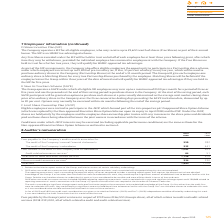According to Intu Properties's financial document, What were the fees payable by the Group's joint ventures in 2019? According to the financial document, £156,000. The relevant text states: "the Group’s joint ventures in respect of 2019 were £156,000 (Group’s share), all of which relates to audit and audit-related services (2018: £121,000, all of wh..." Also, What were the fees payable related to audit and audit-related services in 2018? According to the financial document, £121,000. The relevant text states: "relates to audit and audit-related services (2018: £121,000, all of which related to audit and audit-related services)...." Also, What is the total fees in 2019? According to the financial document, 1,690 (in thousands). The relevant text states: "Total fees 1,690 1,104..." Also, can you calculate: What is the percentage change in the total fees from 2018 to 2019? To answer this question, I need to perform calculations using the financial data. The calculation is: (1,690-1,104)/1,104, which equals 53.08 (percentage). This is based on the information: "Total fees 1,690 1,104 Total fees 1,690 1,104..." The key data points involved are: 1,104, 1,690. Also, can you calculate: What is the percentage change in the audit-related assurance services from 2018 to 2019? To answer this question, I need to perform calculations using the financial data. The calculation is: (64-51)/51, which equals 25.49 (percentage). This is based on the information: "Audit-related assurance services 1 64 51 Audit-related assurance services 1 64 51..." The key data points involved are: 51, 64. Also, can you calculate: What is the percentage of other non-audit assurance services in total fees in 2019? Based on the calculation: 534/1,690, the result is 31.6 (percentage). This is based on the information: "Total fees 1,690 1,104 Other non-audit assurance services 2 534 230..." The key data points involved are: 1,690, 534. 